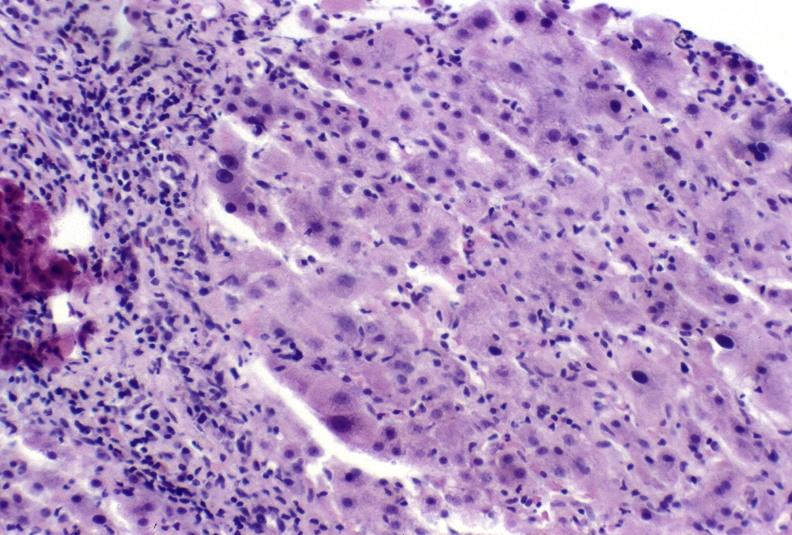s hepatobiliary present?
Answer the question using a single word or phrase. Yes 